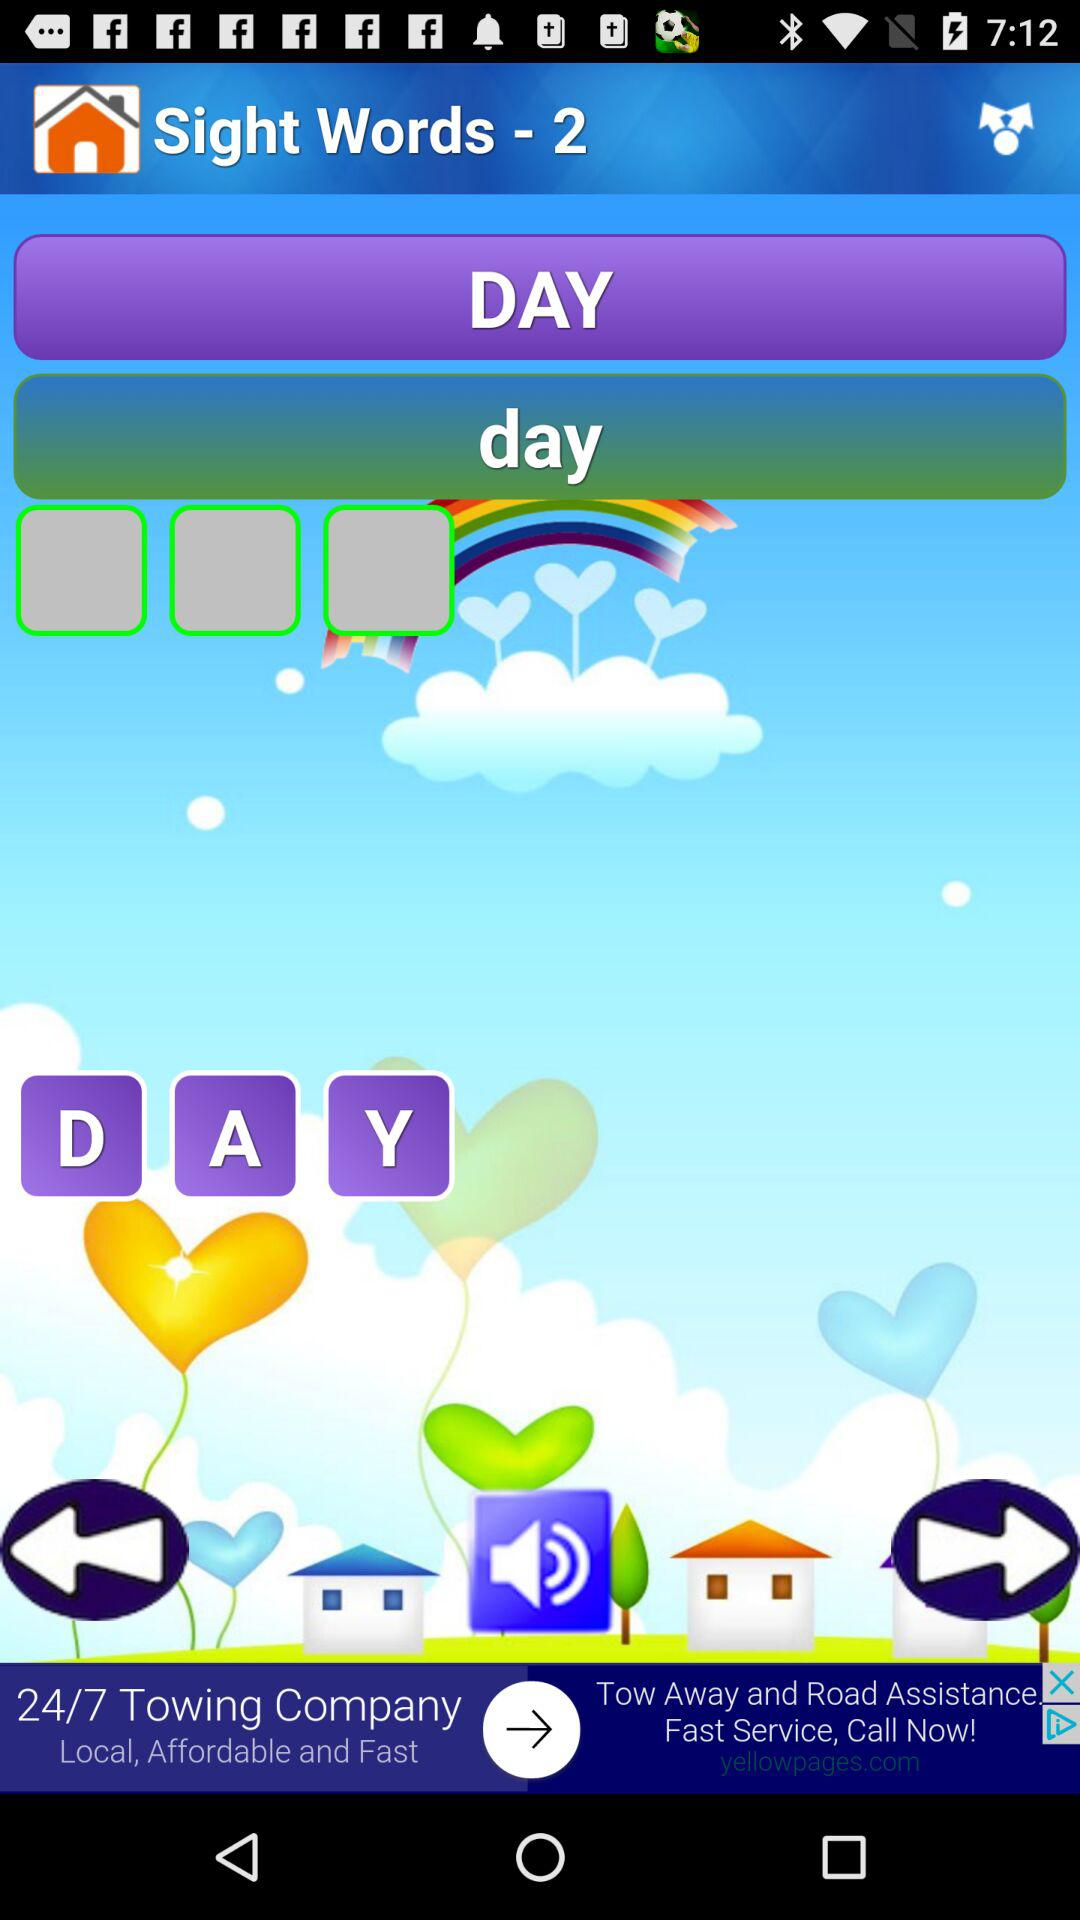What is the application name? The application name is "Sight Words". 